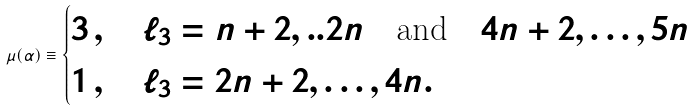<formula> <loc_0><loc_0><loc_500><loc_500>\mu ( \alpha ) \equiv \begin{cases} 3 \, , \quad \ell _ { 3 } = n + 2 , . . 2 n \quad \text {and} \quad 4 n + 2 , \dots , 5 n \\ 1 \, , \quad \ell _ { 3 } = 2 n + 2 , \dots , 4 n . \end{cases}</formula> 